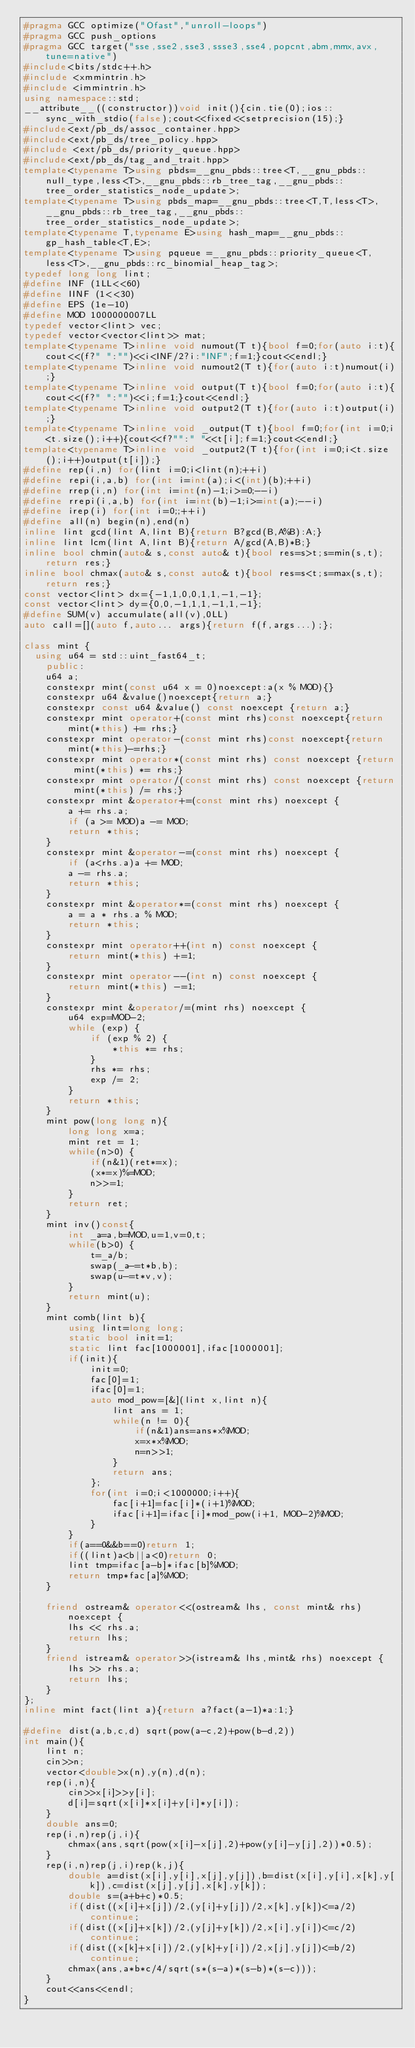<code> <loc_0><loc_0><loc_500><loc_500><_C++_>#pragma GCC optimize("Ofast","unroll-loops")
#pragma GCC push_options
#pragma GCC target("sse,sse2,sse3,ssse3,sse4,popcnt,abm,mmx,avx,tune=native")
#include<bits/stdc++.h>
#include <xmmintrin.h>
#include <immintrin.h>
using namespace::std;
__attribute__((constructor))void init(){cin.tie(0);ios::sync_with_stdio(false);cout<<fixed<<setprecision(15);}
#include<ext/pb_ds/assoc_container.hpp>
#include<ext/pb_ds/tree_policy.hpp>
#include <ext/pb_ds/priority_queue.hpp>
#include<ext/pb_ds/tag_and_trait.hpp>
template<typename T>using pbds=__gnu_pbds::tree<T,__gnu_pbds::null_type,less<T>,__gnu_pbds::rb_tree_tag,__gnu_pbds::tree_order_statistics_node_update>;
template<typename T>using pbds_map=__gnu_pbds::tree<T,T,less<T>,__gnu_pbds::rb_tree_tag,__gnu_pbds::tree_order_statistics_node_update>;
template<typename T,typename E>using hash_map=__gnu_pbds::gp_hash_table<T,E>;
template<typename T>using pqueue =__gnu_pbds::priority_queue<T, less<T>,__gnu_pbds::rc_binomial_heap_tag>;
typedef long long lint;
#define INF (1LL<<60)
#define IINF (1<<30)
#define EPS (1e-10)
#define MOD 1000000007LL
typedef vector<lint> vec;
typedef vector<vector<lint>> mat;
template<typename T>inline void numout(T t){bool f=0;for(auto i:t){cout<<(f?" ":"")<<i<INF/2?i:"INF";f=1;}cout<<endl;}
template<typename T>inline void numout2(T t){for(auto i:t)numout(i);}
template<typename T>inline void output(T t){bool f=0;for(auto i:t){cout<<(f?" ":"")<<i;f=1;}cout<<endl;}
template<typename T>inline void output2(T t){for(auto i:t)output(i);}
template<typename T>inline void _output(T t){bool f=0;for(int i=0;i<t.size();i++){cout<<f?"":" "<<t[i];f=1;}cout<<endl;}
template<typename T>inline void _output2(T t){for(int i=0;i<t.size();i++)output(t[i]);}
#define rep(i,n) for(lint i=0;i<lint(n);++i)
#define repi(i,a,b) for(int i=int(a);i<(int)(b);++i)
#define rrep(i,n) for(int i=int(n)-1;i>=0;--i)
#define rrepi(i,a,b) for(int i=int(b)-1;i>=int(a);--i)
#define irep(i) for(int i=0;;++i)
#define all(n) begin(n),end(n)
inline lint gcd(lint A,lint B){return B?gcd(B,A%B):A;}
inline lint lcm(lint A,lint B){return A/gcd(A,B)*B;}
inline bool chmin(auto& s,const auto& t){bool res=s>t;s=min(s,t);return res;}
inline bool chmax(auto& s,const auto& t){bool res=s<t;s=max(s,t);return res;}
const vector<lint> dx={-1,1,0,0,1,1,-1,-1};
const vector<lint> dy={0,0,-1,1,1,-1,1,-1};
#define SUM(v) accumulate(all(v),0LL)
auto call=[](auto f,auto... args){return f(f,args...);};

class mint {
  using u64 = std::uint_fast64_t;
    public:
    u64 a;
    constexpr mint(const u64 x = 0)noexcept:a(x % MOD){}
    constexpr u64 &value()noexcept{return a;}
    constexpr const u64 &value() const noexcept {return a;}
    constexpr mint operator+(const mint rhs)const noexcept{return mint(*this) += rhs;}
    constexpr mint operator-(const mint rhs)const noexcept{return mint(*this)-=rhs;}
    constexpr mint operator*(const mint rhs) const noexcept {return mint(*this) *= rhs;}
    constexpr mint operator/(const mint rhs) const noexcept {return mint(*this) /= rhs;}
    constexpr mint &operator+=(const mint rhs) noexcept {
        a += rhs.a;
        if (a >= MOD)a -= MOD;
        return *this;
    }
    constexpr mint &operator-=(const mint rhs) noexcept {
        if (a<rhs.a)a += MOD;
        a -= rhs.a;
        return *this;
    }
    constexpr mint &operator*=(const mint rhs) noexcept {
        a = a * rhs.a % MOD;
        return *this;
    }
    constexpr mint operator++(int n) const noexcept {
        return mint(*this) +=1;
    }
    constexpr mint operator--(int n) const noexcept {
        return mint(*this) -=1;
    }
    constexpr mint &operator/=(mint rhs) noexcept {
        u64 exp=MOD-2;
        while (exp) {
            if (exp % 2) {
                *this *= rhs;
            }
            rhs *= rhs;
            exp /= 2;
        }
        return *this;
    }
    mint pow(long long n){
        long long x=a;
        mint ret = 1;
        while(n>0) {
            if(n&1)(ret*=x);
            (x*=x)%=MOD;
            n>>=1;
        }
        return ret;
    }
    mint inv()const{
        int _a=a,b=MOD,u=1,v=0,t;
        while(b>0) {
            t=_a/b;
            swap(_a-=t*b,b);
            swap(u-=t*v,v);
        }
        return mint(u);
    }
    mint comb(lint b){
        using lint=long long;
        static bool init=1;
        static lint fac[1000001],ifac[1000001];
        if(init){
            init=0;
            fac[0]=1;
            ifac[0]=1;
            auto mod_pow=[&](lint x,lint n){
                lint ans = 1;
                while(n != 0){
                    if(n&1)ans=ans*x%MOD;
                    x=x*x%MOD;
                    n=n>>1;
                }
                return ans;
            };
            for(int i=0;i<1000000;i++){
                fac[i+1]=fac[i]*(i+1)%MOD;
                ifac[i+1]=ifac[i]*mod_pow(i+1, MOD-2)%MOD;
            }
        }
        if(a==0&&b==0)return 1;
        if((lint)a<b||a<0)return 0;
        lint tmp=ifac[a-b]*ifac[b]%MOD;
        return tmp*fac[a]%MOD;
    }
    
    friend ostream& operator<<(ostream& lhs, const mint& rhs) noexcept {
        lhs << rhs.a;
        return lhs;
    }
    friend istream& operator>>(istream& lhs,mint& rhs) noexcept {
        lhs >> rhs.a;
        return lhs;
    }
};
inline mint fact(lint a){return a?fact(a-1)*a:1;}

#define dist(a,b,c,d) sqrt(pow(a-c,2)+pow(b-d,2))
int main(){
    lint n;
    cin>>n;
    vector<double>x(n),y(n),d(n);
    rep(i,n){
        cin>>x[i]>>y[i];
        d[i]=sqrt(x[i]*x[i]+y[i]*y[i]);
    }
    double ans=0;
    rep(i,n)rep(j,i){
        chmax(ans,sqrt(pow(x[i]-x[j],2)+pow(y[i]-y[j],2))*0.5);
    }
    rep(i,n)rep(j,i)rep(k,j){
        double a=dist(x[i],y[i],x[j],y[j]),b=dist(x[i],y[i],x[k],y[k]),c=dist(x[j],y[j],x[k],y[k]);
        double s=(a+b+c)*0.5;
        if(dist((x[i]+x[j])/2,(y[i]+y[j])/2,x[k],y[k])<=a/2)continue;
        if(dist((x[j]+x[k])/2,(y[j]+y[k])/2,x[i],y[i])<=c/2)continue;
        if(dist((x[k]+x[i])/2,(y[k]+y[i])/2,x[j],y[j])<=b/2)continue;
        chmax(ans,a*b*c/4/sqrt(s*(s-a)*(s-b)*(s-c)));
    }
    cout<<ans<<endl;
}</code> 